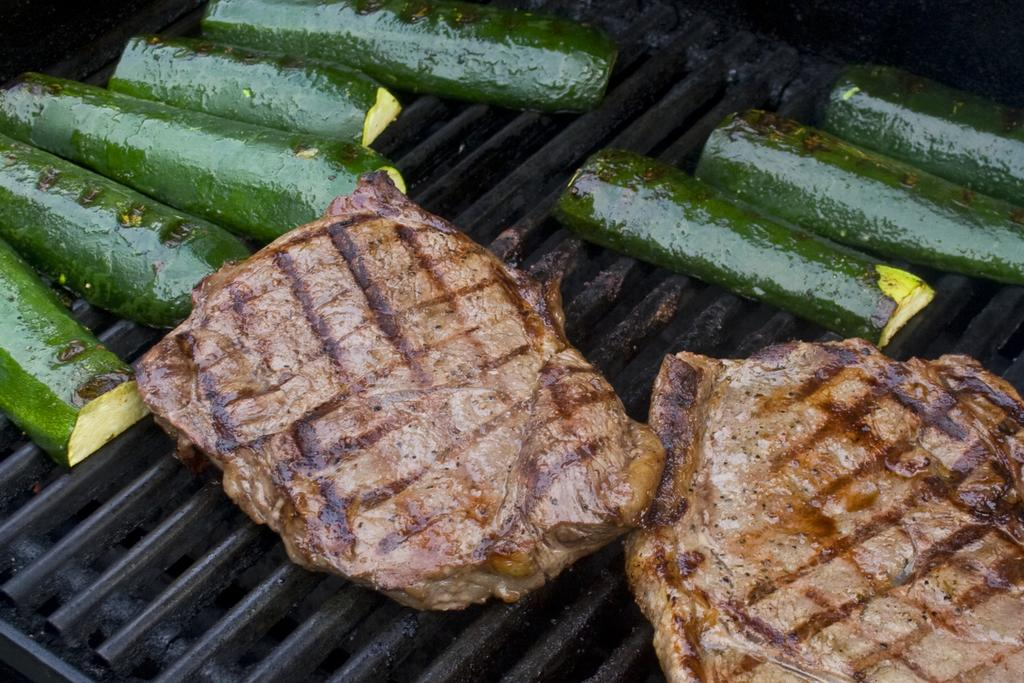What is the main object in the image? There is a grille in the image. How is the grille described in the image? The grille is truncated. What is on the grille in the image? There is food on the grille. How is the food on the grille described? The food is truncated. What type of toys can be seen on the scale in the image? There are no toys or scale present in the image. How does the ice on the grille affect the taste of the food? There is no ice present in the image, so it cannot affect the taste of the food. 